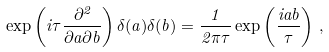Convert formula to latex. <formula><loc_0><loc_0><loc_500><loc_500>\exp \left ( i \tau \frac { \, \partial ^ { 2 } } { \partial a \partial b } \right ) \delta ( a ) \delta ( b ) = \frac { 1 } { 2 \pi \tau } \exp \left ( \frac { i a b } { \tau } \right ) \, ,</formula> 